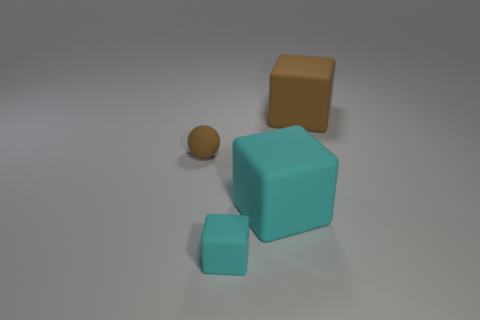Subtract all blocks. How many objects are left? 1 Subtract 1 blocks. How many blocks are left? 2 Subtract all cyan balls. Subtract all yellow cylinders. How many balls are left? 1 Subtract all yellow balls. How many brown blocks are left? 1 Subtract all large yellow shiny things. Subtract all big cyan rubber blocks. How many objects are left? 3 Add 2 matte things. How many matte things are left? 6 Add 3 big green cylinders. How many big green cylinders exist? 3 Add 1 large cyan rubber cubes. How many objects exist? 5 Subtract all brown cubes. How many cubes are left? 2 Subtract all cyan blocks. How many blocks are left? 1 